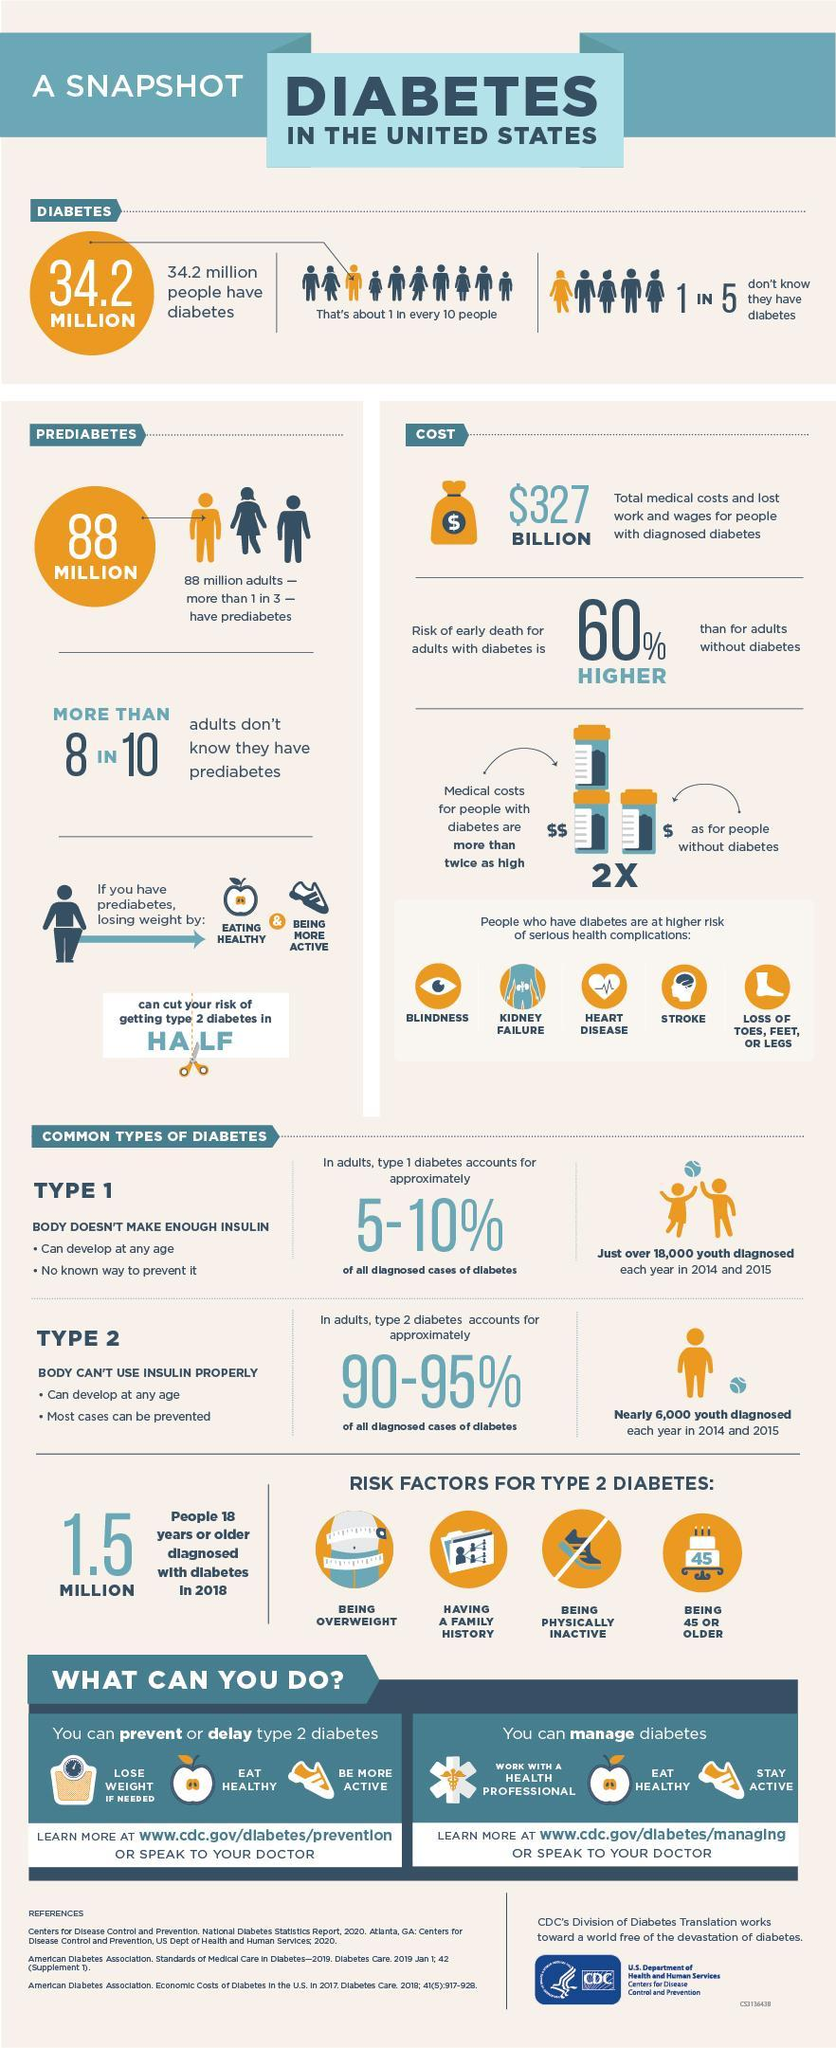how many categories are shown as risk factors for type 2 diabetes
Answer the question with a short phrase. 4 what can diabetes cause to the eyes blindness what can happen if you eat healthy and be more active cut your risk of getting type 2 diabetes in half what is the percentage of adults who don't know they have prediabetics 80 how many youth were diagnosed with type 1 diabetes in 2014 and 2015 18,000 what type of diabetes can be prevented type 2 what is the percentage of people who dont know they have diabetics 20 what is the percentage of diabetics 10 